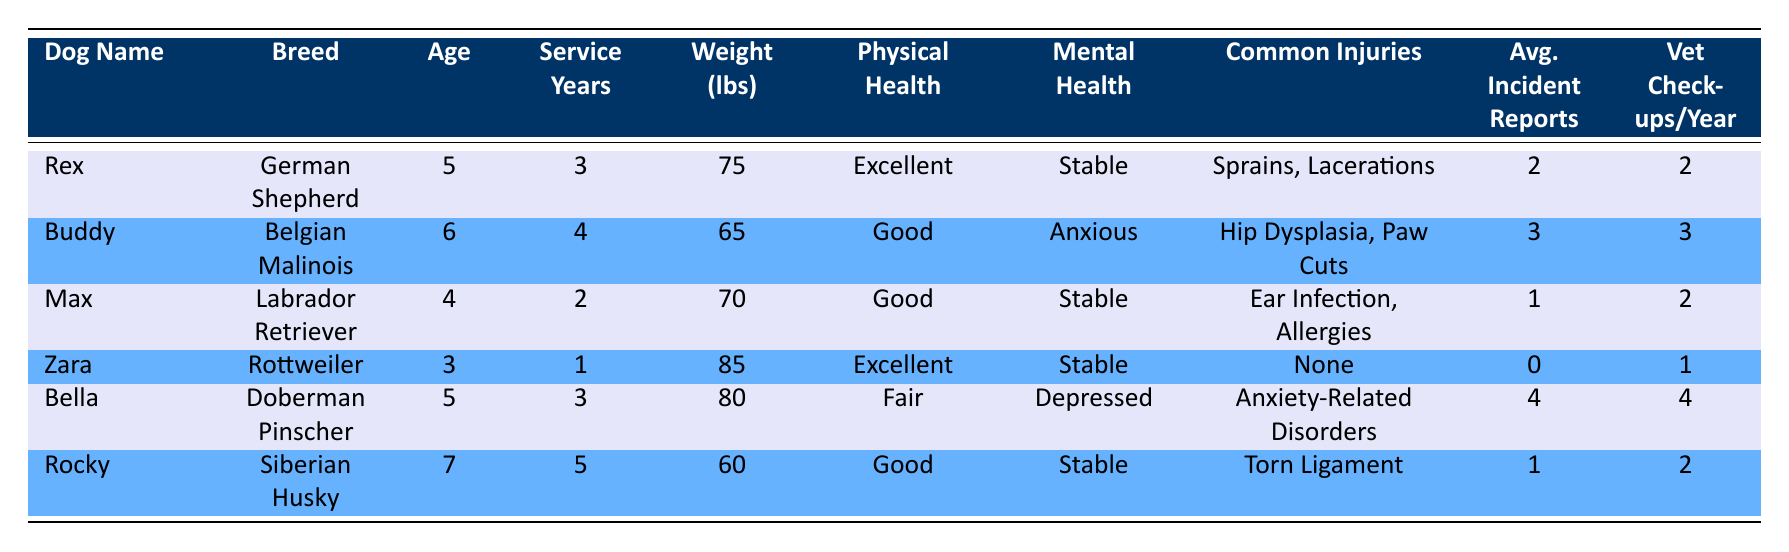What is the Physical Health Status of Bella? According to the table, Bella is listed with a Physical Health Status categorized as "Fair." This information can be found directly under the Physical Health column for Bella.
Answer: Fair How many Veterinary Checkups does Rex have per year? The table shows that Rex has 2 Veterinary Checkups per Year. This is directly listed in the corresponding column for Rex.
Answer: 2 Which dog has the highest Average Incident Reports? Upon reviewing the Average Incident Reports column, Bella has the highest value with 4 incident reports. This requires checking all the values in that column and comparing them to find the maximum.
Answer: 4 Is Max older than Rocky? By comparing the Age column for both dogs, Max is 4 years old while Rocky is 7 years old. Therefore, Max is not older than Rocky.
Answer: No What is the average weight of the dogs with Excellent Physical Health Status? To find the average weight of dogs rated Excellent in Physical Health, we first identify the weights: Rex (75 lbs) and Zara (85 lbs). We sum these weights (75 + 85 = 160 lbs) and divide by the number of dogs (2), resulting in an average weight of 80 lbs. This requires calculating the sum and dividing by the count of the relevant dogs.
Answer: 80 How many dogs have a Mental Health Status categorized as Stable? From the table, the dogs with a Mental Health Status of Stable are Rex, Max, Zara, and Rocky. Counting these entries, we find there are 4 dogs with that status.
Answer: 4 Are there any dogs with no Common Injuries? Checking the Common Injuries column, Zara is the only dog listed with no Common Injuries indicated. This requires looking for entries marked as "None."
Answer: Yes What is the total number of Service Years of all dogs listed in the table? To find the total Service Years, we add the years served by each dog: Rex (3) + Buddy (4) + Max (2) + Zara (1) + Bella (3) + Rocky (5) = 18. This step involves simply summing the Service Years from all entries.
Answer: 18 Which breeds are represented by dogs with a Mental Health Status classified as Anxious? The only dog listed with a Mental Health Status of Anxious is Buddy, who is a Belgian Malinois. This is determined by filtering the table for that specific mental health classification.
Answer: Belgian Malinois 